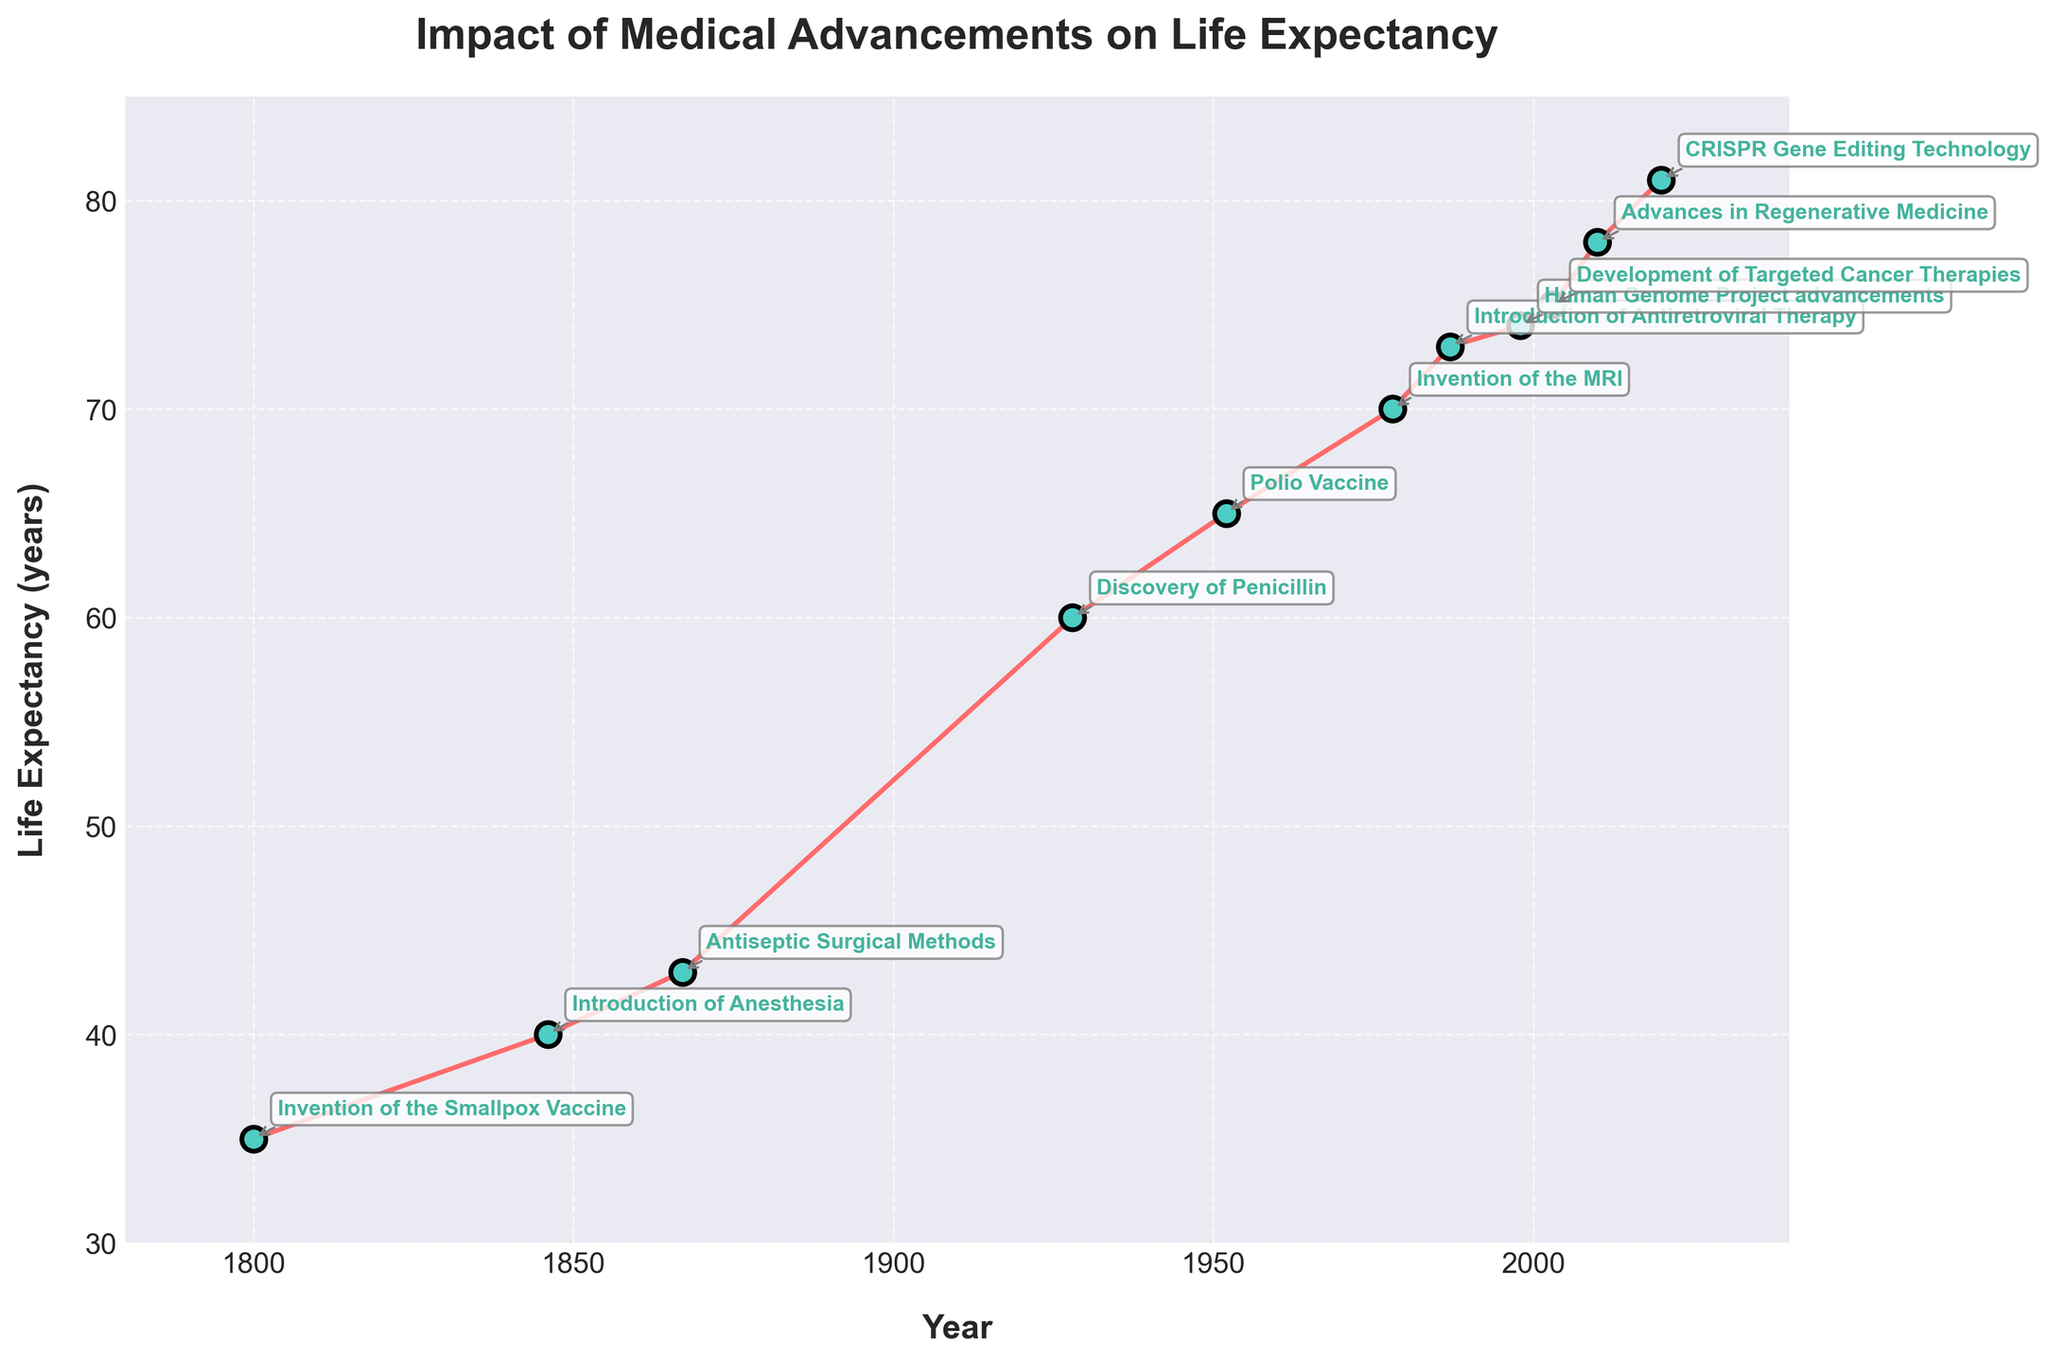What is the title of the figure? The title of the figure is usually displayed at the top. Here, the title is "Impact of Medical Advancements on Life Expectancy".
Answer: Impact of Medical Advancements on Life Expectancy What are the x-axis and y-axis labels in the figure? The labels on the axes provide context. The x-axis label is "Year" and the y-axis label is "Life Expectancy (years)".
Answer: Year, Life Expectancy (years) Which medical technology advancement occurred in 1928? The plot annotates each point with the medical advancements. The advancement in 1928 is the Discovery of Penicillin.
Answer: Discovery of Penicillin How many years does the plot cover? The plot spans from 1800 to 2020. Subtracting these gives a period of 220 years.
Answer: 220 years What is the highest recorded life expectancy in the figure? The highest life expectancy was recorded in 2020, with a value of 81 years.
Answer: 81 years During which period did life expectancy see the biggest increase, and by how much? By comparing adjacent data points, the biggest increase is between 1867 (43 years) and 1928 (60 years), which is a 17-year increase.
Answer: 1867-1928, 17 years Which medical advancement led to a life expectancy of 70 years? The annotation closest to the 70-year mark on the y-axis and corresponding year on the x-axis (1978) is the Invention of the MRI.
Answer: Invention of the MRI How much did life expectancy increase between 1800 and 1846? The life expectancy in 1800 was 35 years and in 1846 was 40 years. The increase is \(40 - 35 = 5\) years.
Answer: 5 years Are there any periods where life expectancy remained the same or changed very little? From 1987 to 1998, life expectancy increased from 73 to 74 years. This 11-year period shows the smallest increase.
Answer: 1987-1998 What is the average life expectancy across all recorded years in the figure? To find the average: Add all life expectancies (\(35 + 40 + 43 + 60 + 65 + 70 + 73 + 74 + 75 + 78 + 81 = 694\)) and divide by the number of years (11). \(694 / 11 \approx 63.1\) years.
Answer: 63.1 years 